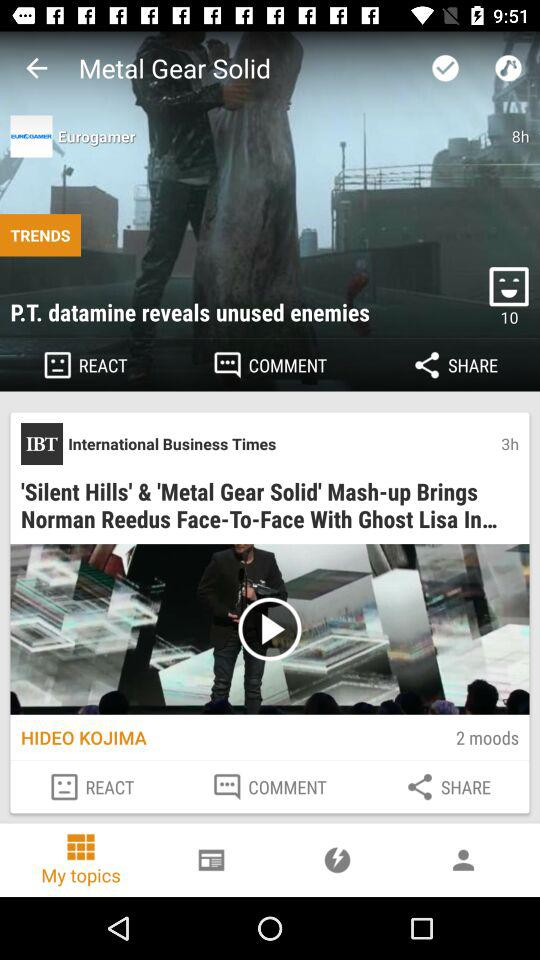What is the full form of IBT? The full form of IBT is International Business Times. 